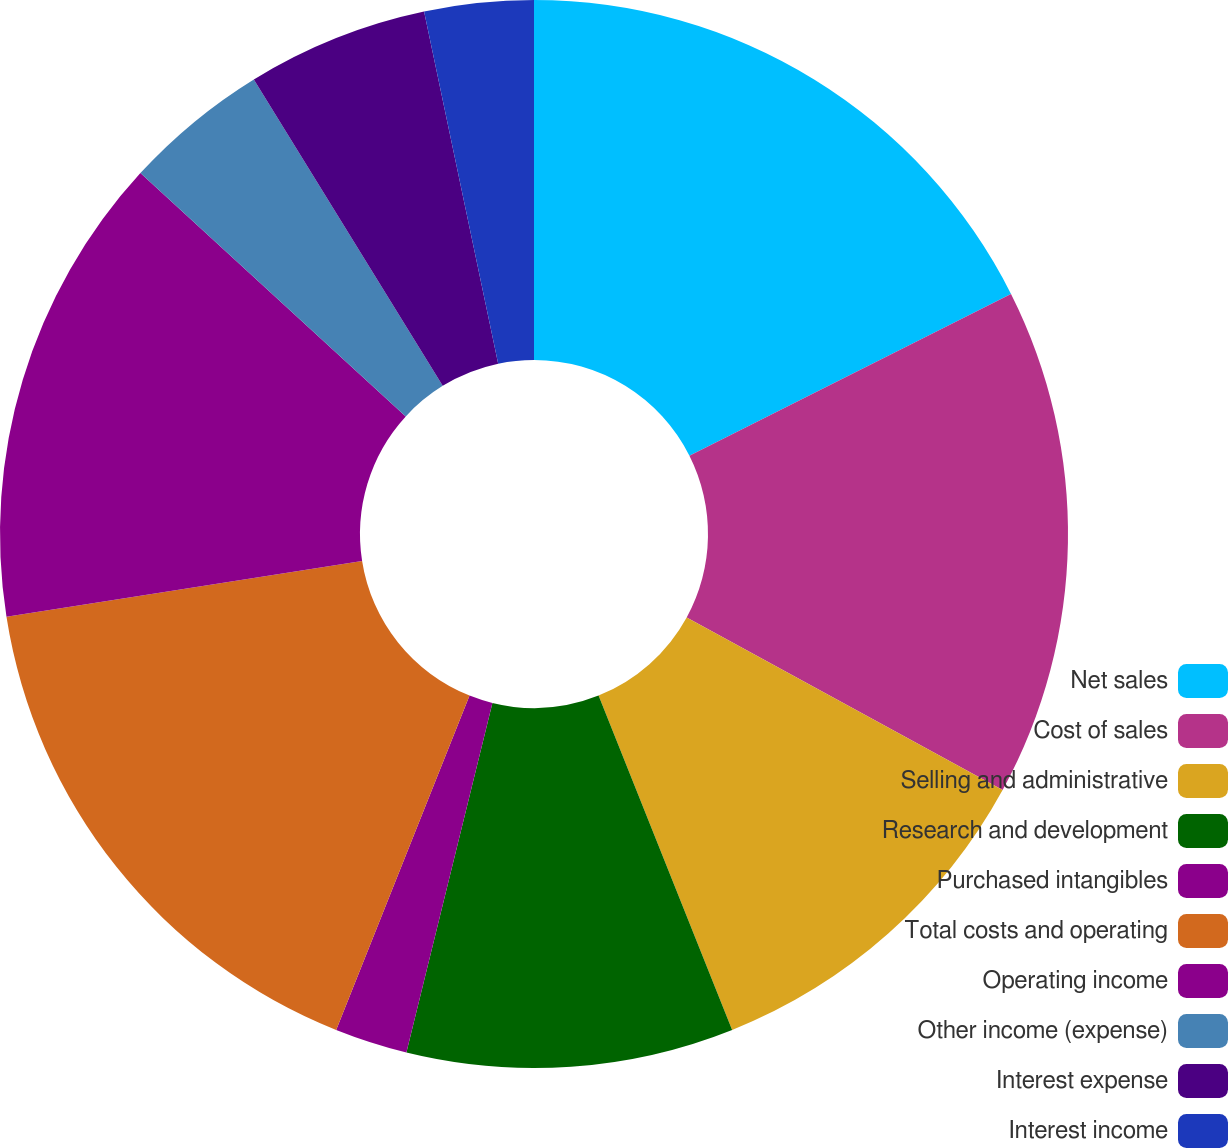Convert chart. <chart><loc_0><loc_0><loc_500><loc_500><pie_chart><fcel>Net sales<fcel>Cost of sales<fcel>Selling and administrative<fcel>Research and development<fcel>Purchased intangibles<fcel>Total costs and operating<fcel>Operating income<fcel>Other income (expense)<fcel>Interest expense<fcel>Interest income<nl><fcel>17.58%<fcel>15.38%<fcel>10.99%<fcel>9.89%<fcel>2.2%<fcel>16.48%<fcel>14.29%<fcel>4.4%<fcel>5.49%<fcel>3.3%<nl></chart> 